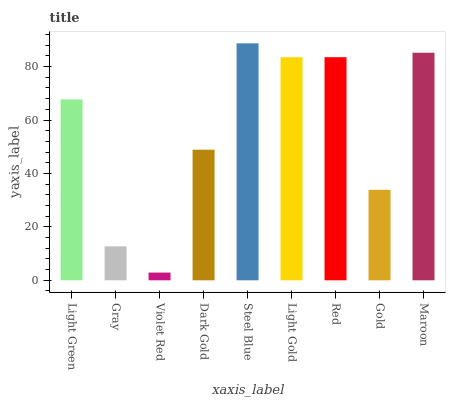Is Gray the minimum?
Answer yes or no. No. Is Gray the maximum?
Answer yes or no. No. Is Light Green greater than Gray?
Answer yes or no. Yes. Is Gray less than Light Green?
Answer yes or no. Yes. Is Gray greater than Light Green?
Answer yes or no. No. Is Light Green less than Gray?
Answer yes or no. No. Is Light Green the high median?
Answer yes or no. Yes. Is Light Green the low median?
Answer yes or no. Yes. Is Light Gold the high median?
Answer yes or no. No. Is Violet Red the low median?
Answer yes or no. No. 